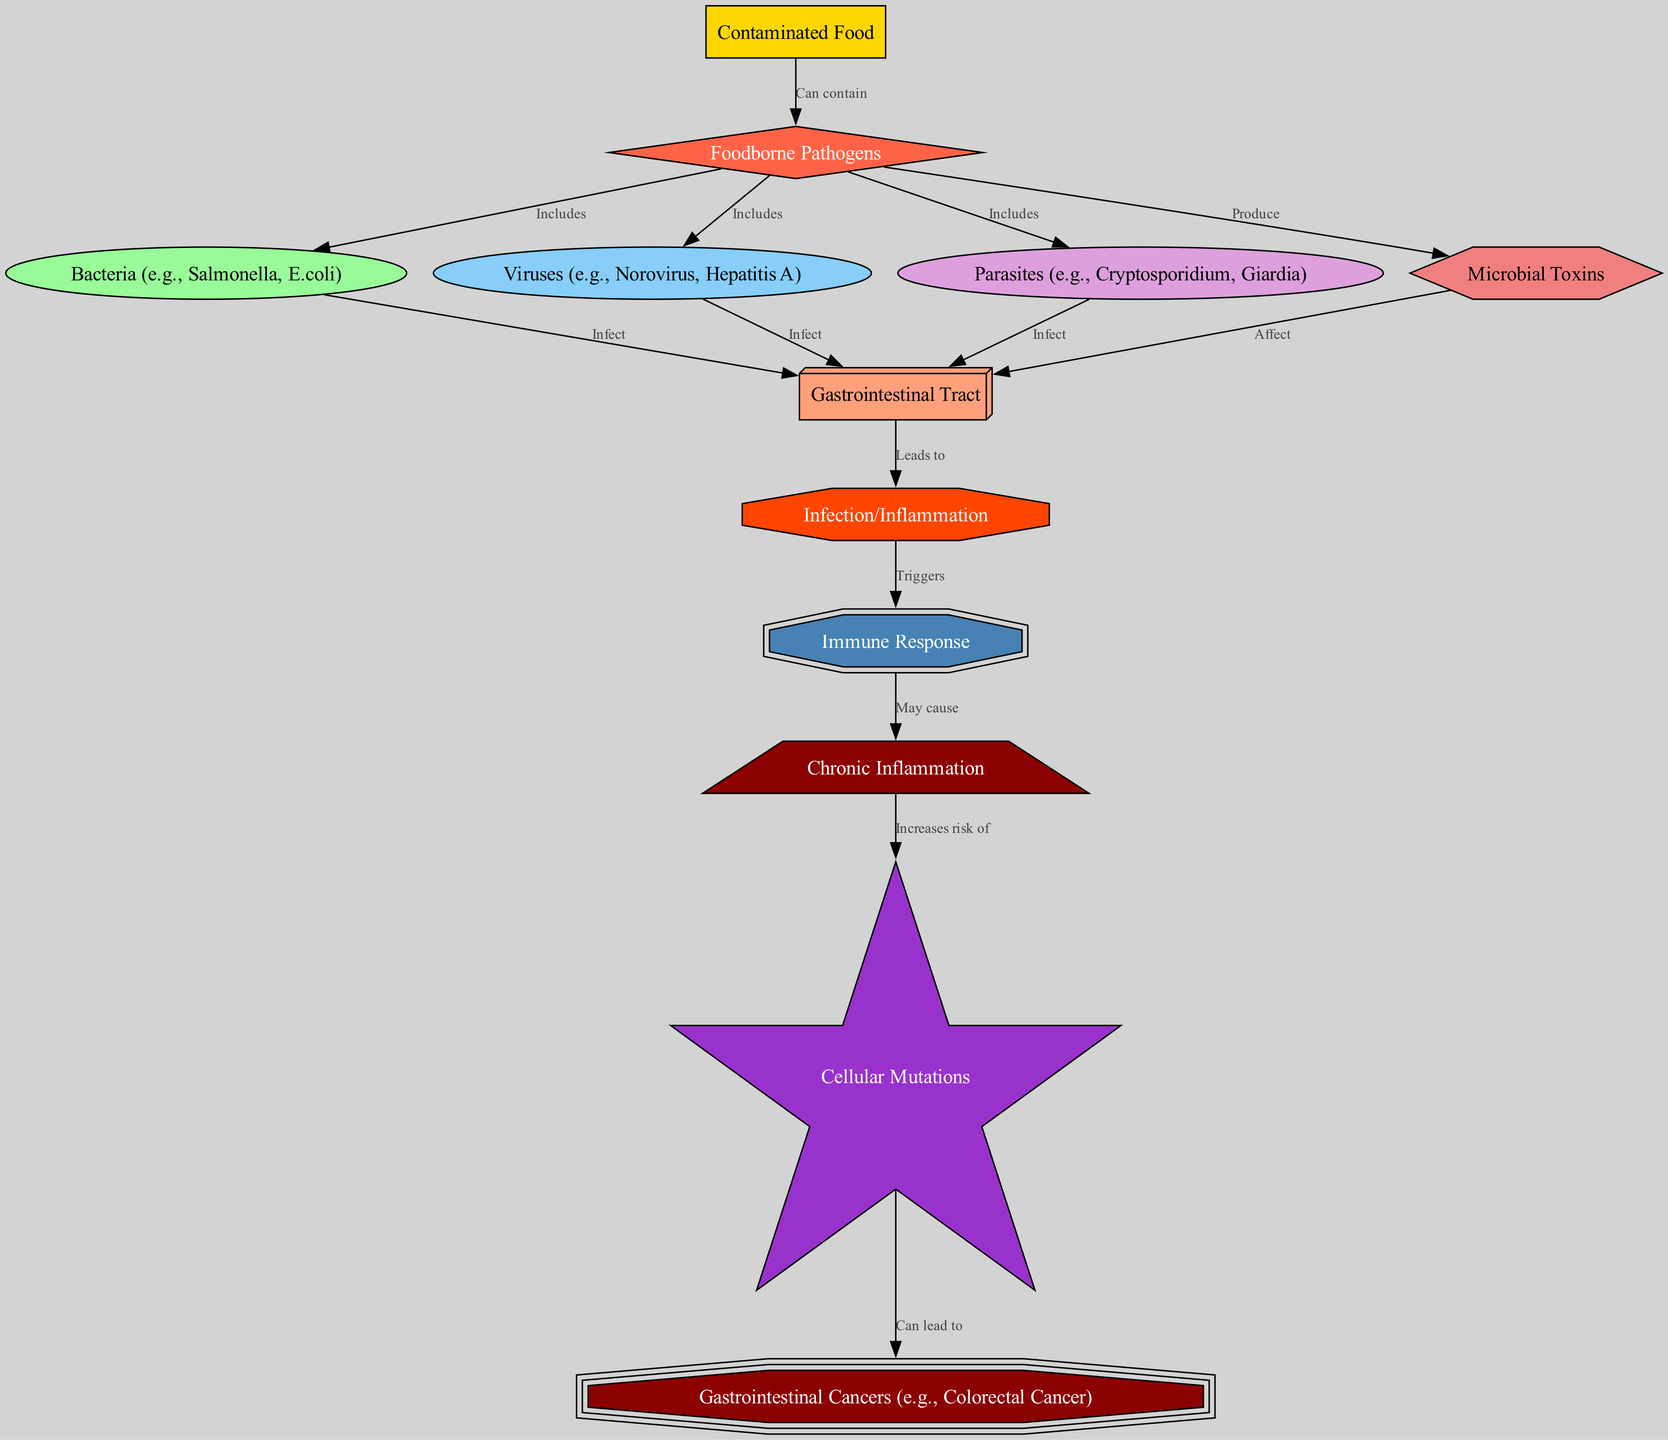What is the starting point of the food chain? The starting point of the food chain is "Contaminated Food," which is where foodborne pathogens originate. The diagram clearly indicates this as the first node.
Answer: Contaminated Food How many types of pathogens are included in the diagram? The diagram includes three types of pathogens: bacteria, viruses, and parasites. Each of these is represented as nodes connected to the path "Foodborne Pathogens."
Answer: Three What does "Infection/Inflammation" trigger in the immune system? According to the diagram, "Infection/Inflammation" triggers the "Immune Response." The arrow from "Infection/Inflammation" to "Immune Response" indicates this relationship.
Answer: Immune Response What is the relationship between "Chronic Inflammation" and "Cellular Mutations"? The diagram shows that "Chronic Inflammation" increases the risk of "Cellular Mutations." This is indicated by the arrow connecting these two nodes with the specific label "Increases risk of."
Answer: Increases risk of What type of foodborne pathogens can contaminate food? The diagram categorizes foodborne pathogens into three types: bacteria, viruses, and parasites, which are all included under "Foodborne Pathogens." This means all these pathogens can contaminate food.
Answer: Bacteria, viruses, parasites How does "Microbial Toxins" affect the gastrointestinal tract? The diagram indicates that "Microbial Toxins" have an effect on the "Gastrointestinal Tract," as evidenced by the connecting arrow labeled "Affect." This leads us to understand that toxins can influence gastrointestinal health.
Answer: Affect Which cancer type is specifically linked to cellular mutations? "Cellular Mutations" can lead to "Gastrointestinal Cancers," specifically mentioned as "Colorectal Cancer" in the diagram. The outgoing arrow indicates this progression.
Answer: Gastrointestinal Cancers What is the pathway from contaminated food to cancer? The pathway starts with "Contaminated Food," which leads to "Foodborne Pathogens," followed by infection of the gastrointestinal tract, triggering an immune response that may cause chronic inflammation, resulting in cellular mutations that can lead to gastrointestinal cancers. This requires reasoning through multiple connections in the diagram.
Answer: Contaminated Food → Foodborne Pathogens → Gastrointestinal Tract → Infection/Inflammation → Immune Response → Chronic Inflammation → Cellular Mutations → Gastrointestinal Cancers What can produce toxins in the food chain? According to the diagram, "Foodborne Pathogens" produce "Microbial Toxins," which is explicitly stated in the labeled edge from pathogens to toxins.
Answer: Foodborne Pathogens 